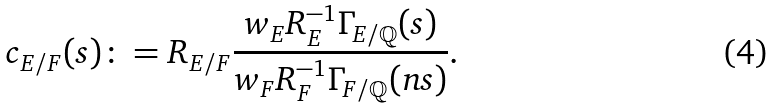<formula> <loc_0><loc_0><loc_500><loc_500>c _ { E / F } ( s ) \colon = R _ { E / F } \frac { w _ { E } R _ { E } ^ { - 1 } \Gamma _ { E / \mathbb { Q } } ( s ) } { w _ { F } R _ { F } ^ { - 1 } \Gamma _ { F / \mathbb { Q } } ( n s ) } .</formula> 